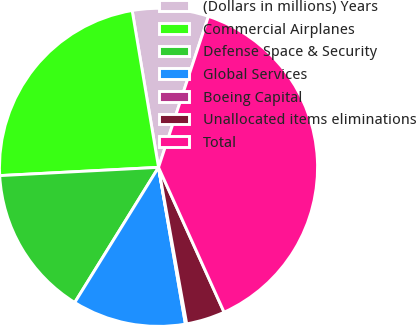<chart> <loc_0><loc_0><loc_500><loc_500><pie_chart><fcel>(Dollars in millions) Years<fcel>Commercial Airplanes<fcel>Defense Space & Security<fcel>Global Services<fcel>Boeing Capital<fcel>Unallocated items eliminations<fcel>Total<nl><fcel>7.73%<fcel>23.18%<fcel>15.34%<fcel>11.54%<fcel>0.13%<fcel>3.93%<fcel>38.16%<nl></chart> 